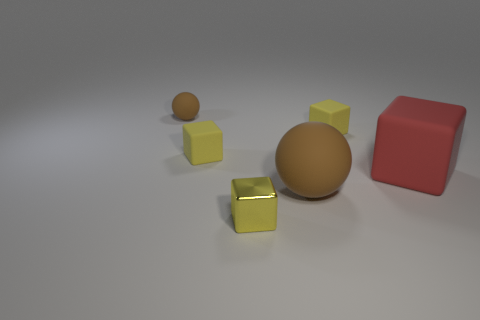Is there anything else that is the same material as the big red object?
Your answer should be very brief. Yes. How many other objects are there of the same shape as the big brown object?
Your response must be concise. 1. Do the red thing that is right of the yellow shiny cube and the brown object that is right of the tiny yellow metal cube have the same size?
Your answer should be compact. Yes. How many balls are small yellow objects or brown rubber things?
Keep it short and to the point. 2. How many matte things are large purple cylinders or brown things?
Ensure brevity in your answer.  2. What is the size of the yellow metal object that is the same shape as the red rubber thing?
Make the answer very short. Small. Is there anything else that is the same size as the red rubber cube?
Your response must be concise. Yes. Do the red rubber thing and the brown ball that is to the left of the large brown ball have the same size?
Give a very brief answer. No. The brown thing in front of the small brown ball has what shape?
Make the answer very short. Sphere. There is a shiny block that is to the right of the brown rubber object that is behind the big rubber sphere; what is its color?
Make the answer very short. Yellow. 